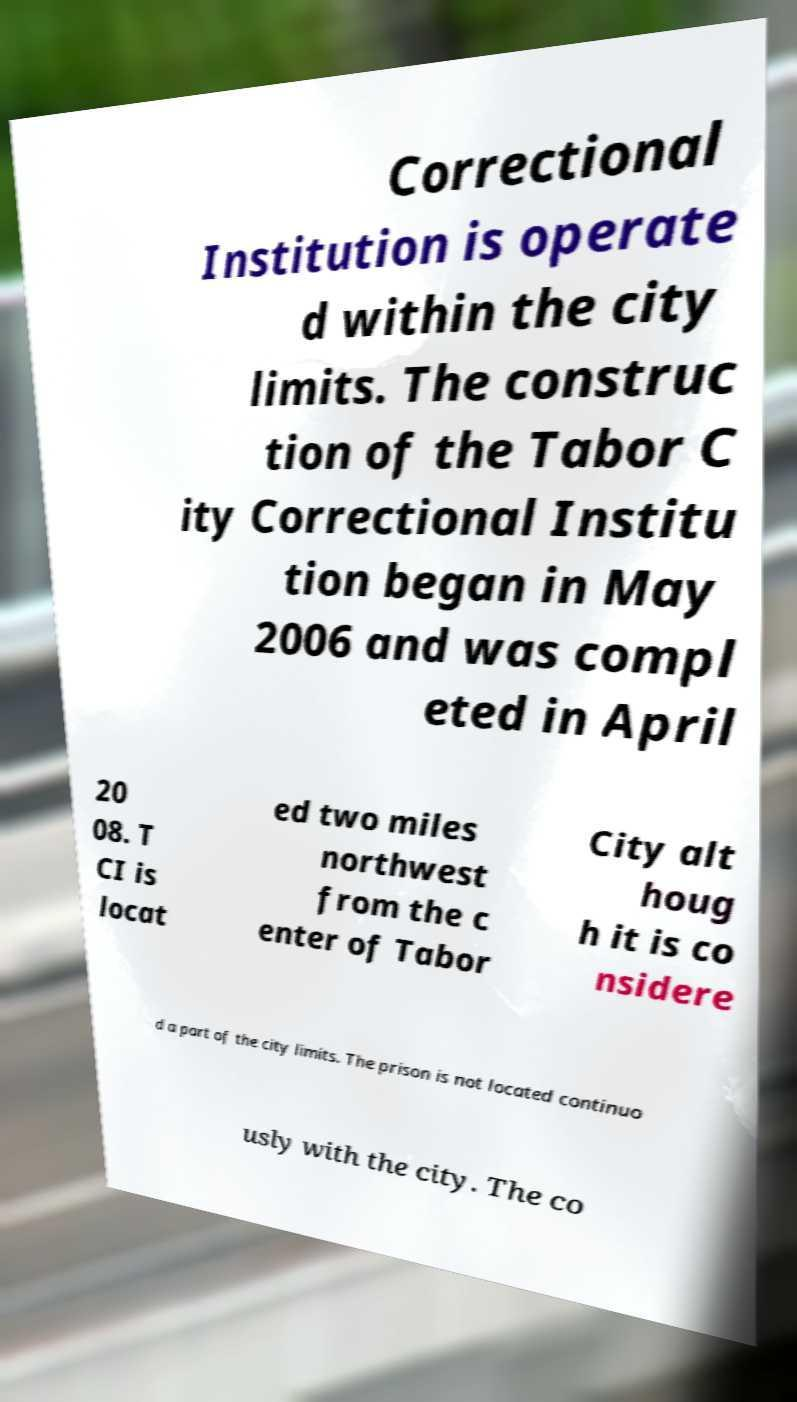Please identify and transcribe the text found in this image. Correctional Institution is operate d within the city limits. The construc tion of the Tabor C ity Correctional Institu tion began in May 2006 and was compl eted in April 20 08. T CI is locat ed two miles northwest from the c enter of Tabor City alt houg h it is co nsidere d a part of the city limits. The prison is not located continuo usly with the city. The co 